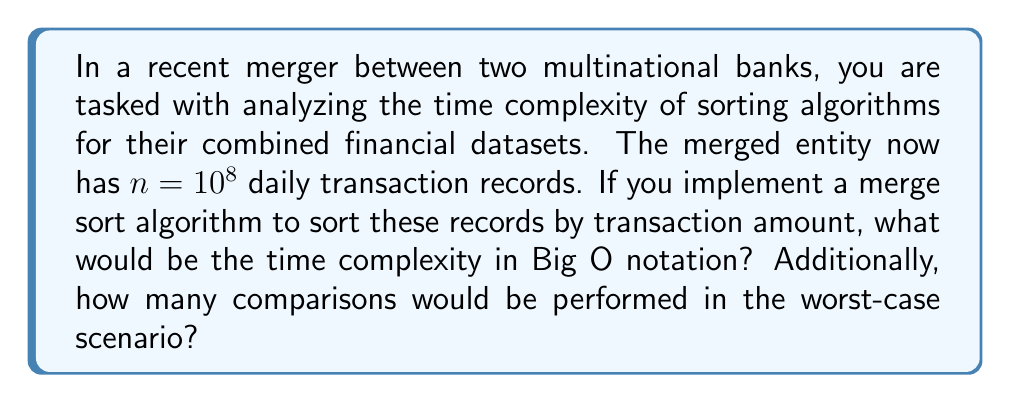Give your solution to this math problem. To answer this question, let's break it down step by step:

1. Merge Sort Time Complexity:
   The time complexity of merge sort is $O(n \log n)$ for all cases (best, average, and worst).

2. Number of Comparisons:
   In the worst-case scenario, merge sort performs approximately $n \log_2 n$ comparisons.

3. Calculating the number of comparisons:
   $$\begin{align}
   \text{Comparisons} &= n \log_2 n \\
   &= 10^8 \log_2 10^8 \\
   &= 10^8 \times \log_2 10^8 \\
   &= 10^8 \times \frac{\log 10^8}{\log 2} \\
   &= 10^8 \times \frac{8 \log 10}{\log 2} \\
   &\approx 10^8 \times 26.58 \\
   &\approx 2.658 \times 10^9
   \end{align}$$

Therefore, the time complexity of the merge sort algorithm for sorting $10^8$ daily transaction records is $O(n \log n)$, and in the worst-case scenario, it would perform approximately $2.658 \times 10^9$ comparisons.
Answer: Time complexity: $O(n \log n)$
Number of comparisons in worst-case: $\approx 2.658 \times 10^9$ 